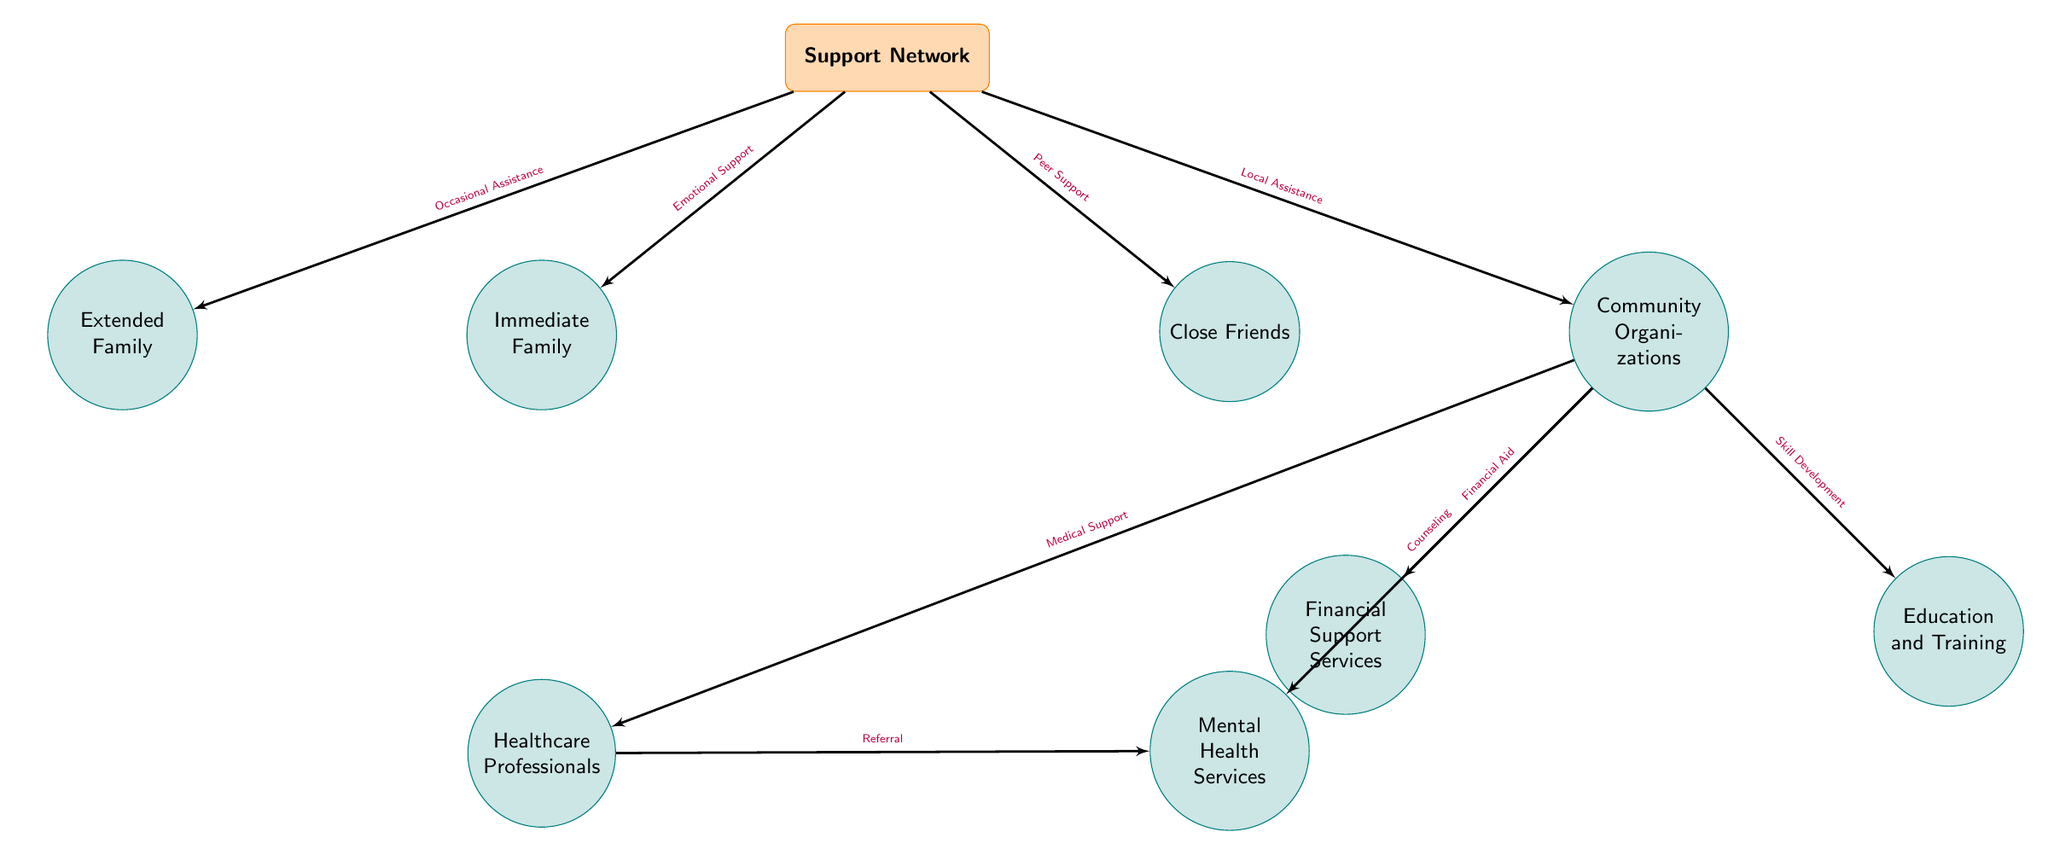What is the main node in the diagram? The main node at the top of the diagram is labeled "Support Network." This is evident as it is the central point from which all other nodes and connections stem.
Answer: Support Network How many nodes are connected to the "Community Organizations" node? The "Community Organizations" node has four branches leading to other nodes: "Healthcare Professionals," "Mental Health Services," "Financial Support Services," and "Education and Training." This indicates there are four connections.
Answer: 4 What type of support does the "Immediate Family" provide? The "Immediate Family" node is connected to the "Support Network" node with an edge labeled "Emotional Support." This clearly indicates the kind of support provided by the immediate family.
Answer: Emotional Support Which node receives referral from "Healthcare Professionals"? In the diagram, there is an edge connecting "Healthcare Professionals" to "Mental Health Services" with the label "Referral." This shows that mental health services receive referrals from healthcare professionals.
Answer: Mental Health Services What type of service is provided by "Community Organizations" to "Healthcare Professionals"? The connection from "Community Organizations" to "Healthcare Professionals" is labeled "Medical Support." This denotes that community organizations provide medical support to healthcare professionals.
Answer: Medical Support How many types of nodes are in the diagram? The diagram displays a total of six nodes for the support system, two main types: primary support connections (like Family, Friends, Community) and secondary support services (like Healthcare Professionals, Mental Health Services). Thus, there are two main types of categories.
Answer: 2 What is the relationship between "Community Organizations" and "Education and Training"? The connection shown between "Community Organizations" and "Education and Training" is labeled "Skill Development." This signifies that community organizations contribute towards education and training through skill development.
Answer: Skill Development Who provides occasional assistance according to the diagram? The "Extended Family" node is directly connected to the "Support Network" with the edge labeled "Occasional Assistance." This outlines the role of the extended family in providing support.
Answer: Extended Family What services are connected to "Community Organizations"? "Community Organizations" provide several services that connect to other nodes: "Medical Support" to Healthcare Professionals, "Counseling" to Mental Health Services, "Financial Aid" to Financial Support Services, and "Skill Development" to Education and Training.
Answer: Medical Support, Counseling, Financial Aid, Skill Development 